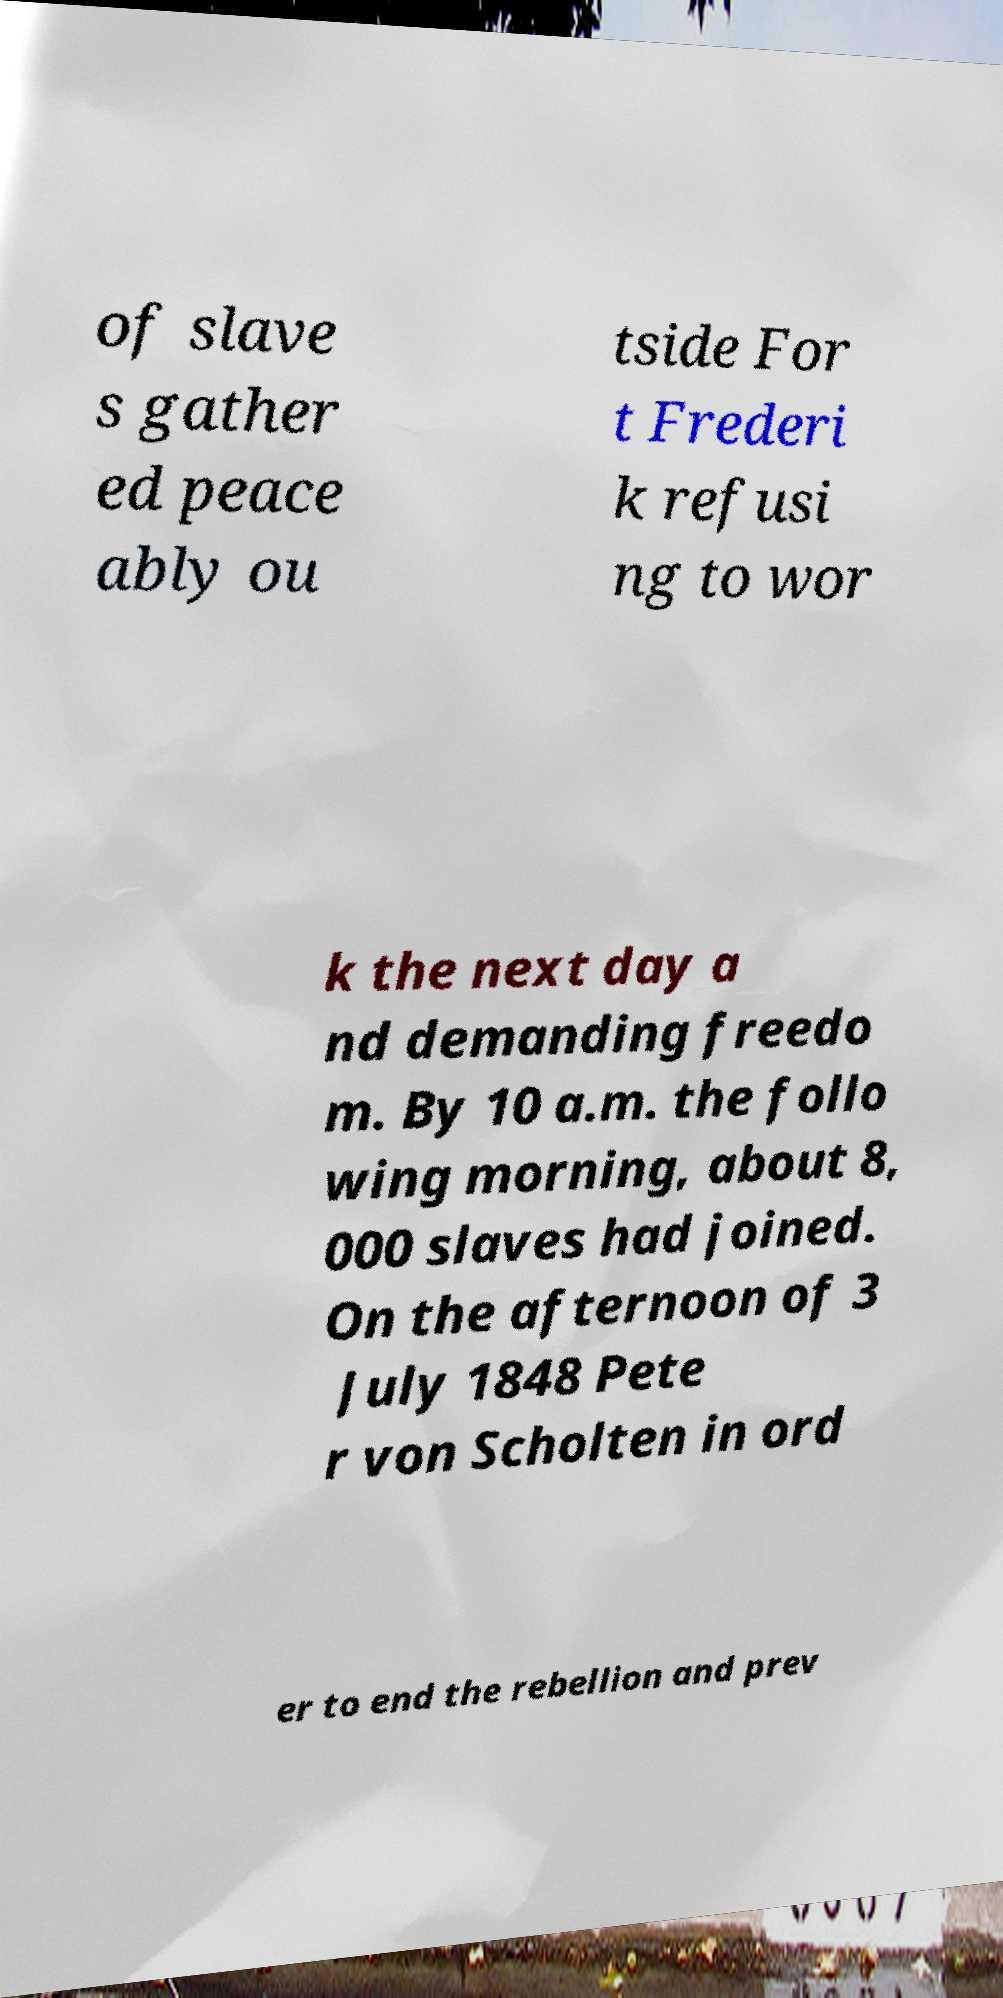There's text embedded in this image that I need extracted. Can you transcribe it verbatim? of slave s gather ed peace ably ou tside For t Frederi k refusi ng to wor k the next day a nd demanding freedo m. By 10 a.m. the follo wing morning, about 8, 000 slaves had joined. On the afternoon of 3 July 1848 Pete r von Scholten in ord er to end the rebellion and prev 